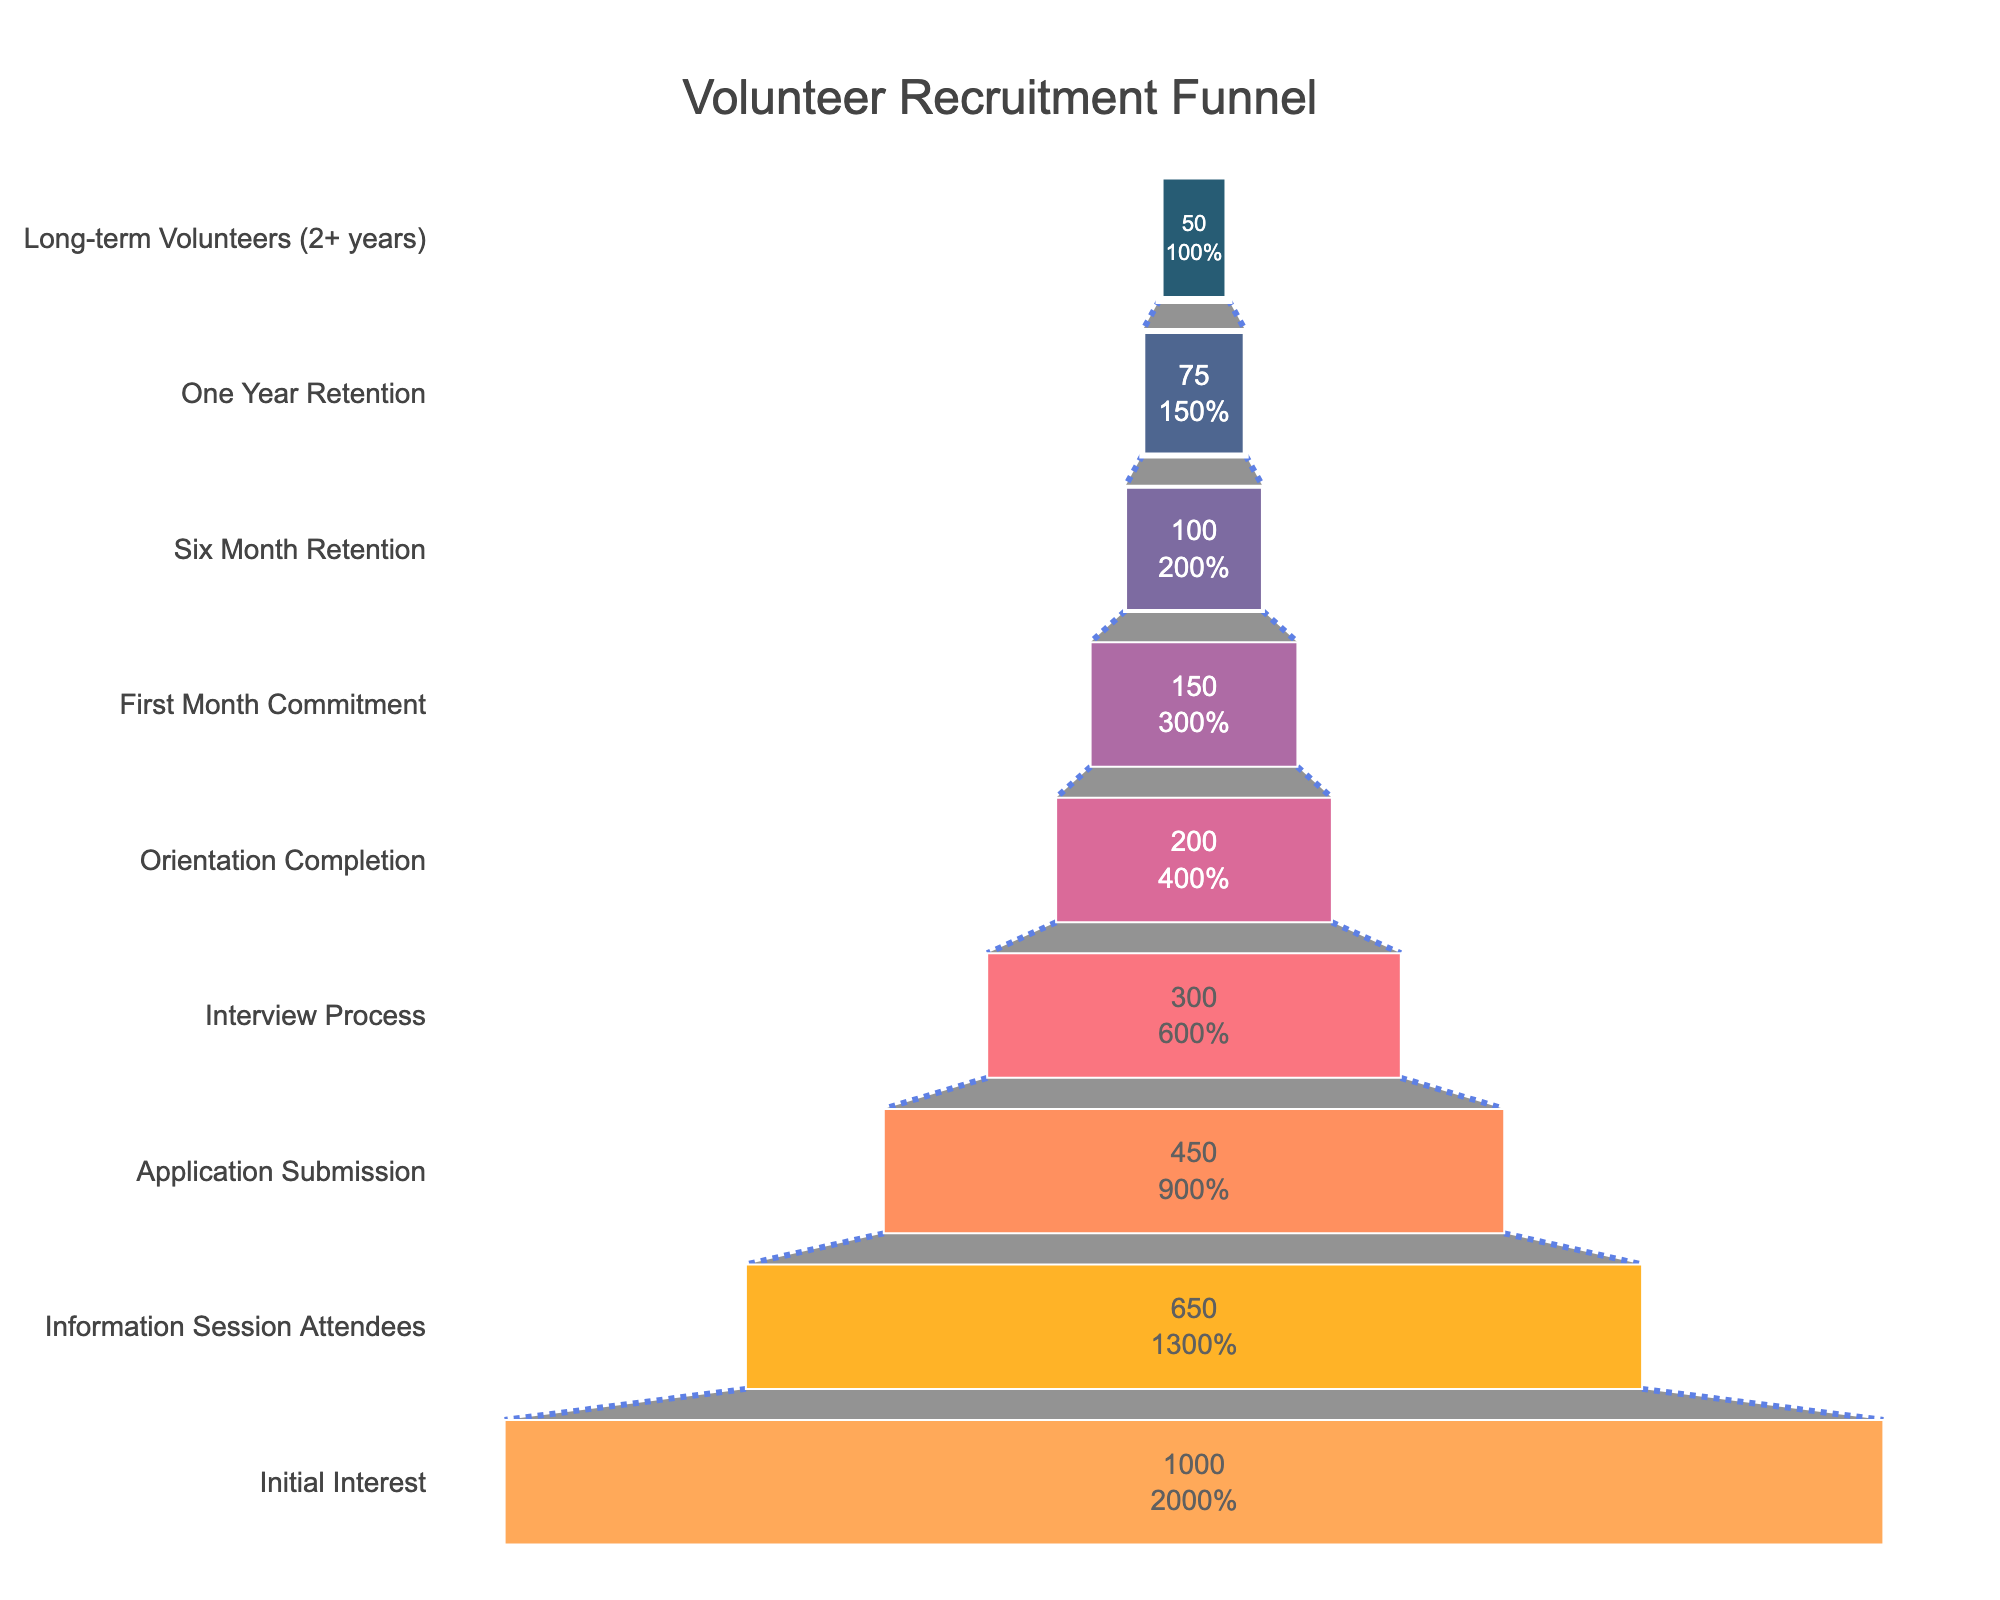what is the title of the chart? The title is located at the top of the chart. It reads "Volunteer Recruitment Funnel," which indicates what the chart is depicting.
Answer: Volunteer Recruitment Funnel how many stages are represented in the funnel chart? By counting the labels on the y-axis, we can determine there are nine stages depicted in the chart.
Answer: 9 how many people attended the information session? We can directly refer to the "Information Session Attendees" stage on the y-axis, which shows a value of 650 people.
Answer: 650 how many fewer people submitted an application compared to attending the information session? Subtract the number of people who submitted an application (450) from the number who attended the information session (650). This results in a difference of 200 people.
Answer: 200 what percentage of the original interested individuals became long-term volunteers? The original number of interested individuals is 1000, and the number of long-term volunteers is 50. Dividing 50 by 1000 and converting to a percentage gives 5%.
Answer: 5% how many more people completed the orientation compared to those who finished the interview process? Subtract the number of people who completed the interview process (300) from those who completed the orientation (200). This indicates 100 more people completed the orientation.
Answer: 100 which stage has the largest drop in the number of people? By inspecting the stages, the largest drop is observed from "Interview Process" (300) to "Orientation Completion" (200) which is a reduction of 100 people.
Answer: Interview Process to Orientation Completion how many people are retained after six months in the program? The "Six Month Retention" stage shows that 100 people are retained after six months.
Answer: 100 which stage has the smallest number of people? The "Long-term Volunteers (2+ years)" stage has the smallest number of people, with only 50 remaining.
Answer: Long-term Volunteers (2+ years) compare the number of people in the first month of commitment to those in the first six months of retention. Which stage sees a higher retention? The "First Month Commitment" stage retains 150 people, while the "Six Month Retention" stage retains 100 people. Therefore, the "First Month Commitment" stage sees higher retention.
Answer: First Month Commitment 